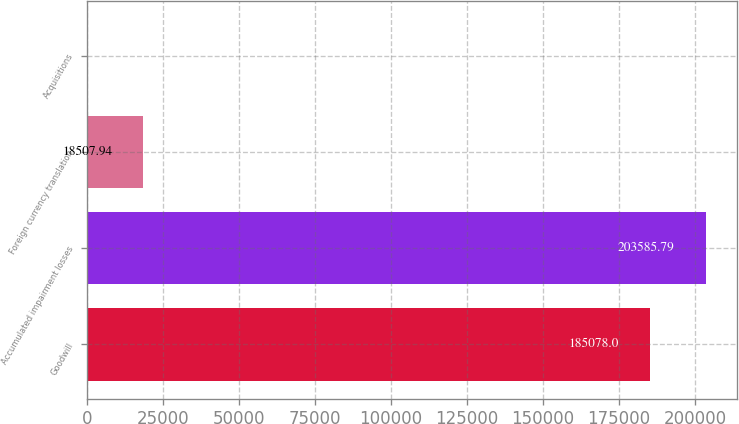Convert chart. <chart><loc_0><loc_0><loc_500><loc_500><bar_chart><fcel>Goodwill<fcel>Accumulated impairment losses<fcel>Foreign currency translation<fcel>Acquisitions<nl><fcel>185078<fcel>203586<fcel>18507.9<fcel>0.15<nl></chart> 